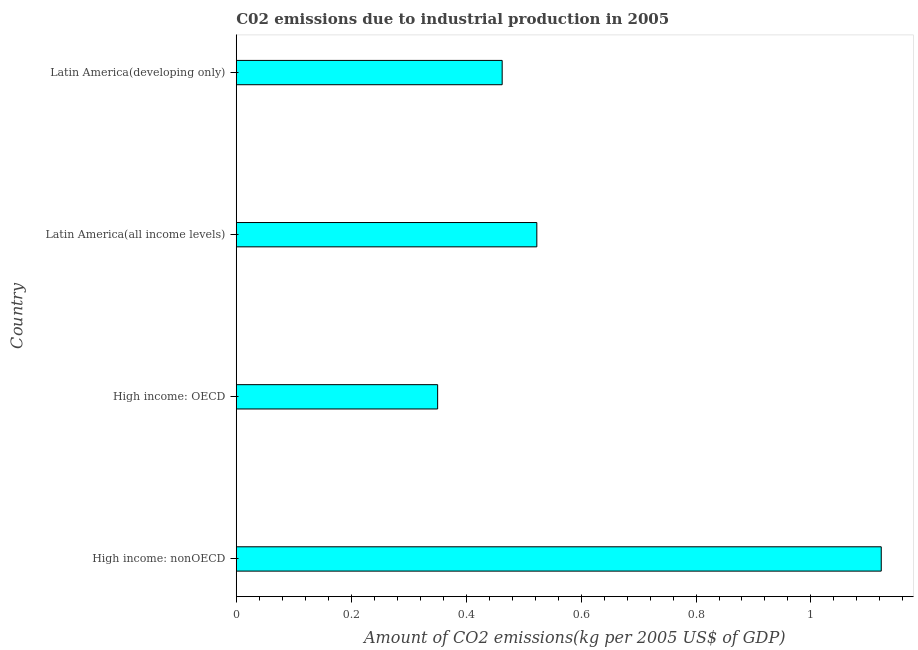Does the graph contain grids?
Provide a succinct answer. No. What is the title of the graph?
Provide a succinct answer. C02 emissions due to industrial production in 2005. What is the label or title of the X-axis?
Provide a succinct answer. Amount of CO2 emissions(kg per 2005 US$ of GDP). What is the amount of co2 emissions in High income: nonOECD?
Your answer should be compact. 1.12. Across all countries, what is the maximum amount of co2 emissions?
Your response must be concise. 1.12. Across all countries, what is the minimum amount of co2 emissions?
Make the answer very short. 0.35. In which country was the amount of co2 emissions maximum?
Your answer should be very brief. High income: nonOECD. In which country was the amount of co2 emissions minimum?
Keep it short and to the point. High income: OECD. What is the sum of the amount of co2 emissions?
Offer a terse response. 2.46. What is the difference between the amount of co2 emissions in High income: OECD and Latin America(developing only)?
Provide a short and direct response. -0.11. What is the average amount of co2 emissions per country?
Keep it short and to the point. 0.61. What is the median amount of co2 emissions?
Provide a succinct answer. 0.49. In how many countries, is the amount of co2 emissions greater than 0.64 kg per 2005 US$ of GDP?
Offer a terse response. 1. What is the ratio of the amount of co2 emissions in High income: nonOECD to that in Latin America(developing only)?
Provide a succinct answer. 2.43. Is the amount of co2 emissions in High income: OECD less than that in Latin America(developing only)?
Your answer should be compact. Yes. What is the difference between the highest and the second highest amount of co2 emissions?
Make the answer very short. 0.6. What is the difference between the highest and the lowest amount of co2 emissions?
Your answer should be very brief. 0.77. What is the difference between two consecutive major ticks on the X-axis?
Your answer should be very brief. 0.2. Are the values on the major ticks of X-axis written in scientific E-notation?
Provide a succinct answer. No. What is the Amount of CO2 emissions(kg per 2005 US$ of GDP) of High income: nonOECD?
Your answer should be very brief. 1.12. What is the Amount of CO2 emissions(kg per 2005 US$ of GDP) of High income: OECD?
Offer a terse response. 0.35. What is the Amount of CO2 emissions(kg per 2005 US$ of GDP) of Latin America(all income levels)?
Keep it short and to the point. 0.52. What is the Amount of CO2 emissions(kg per 2005 US$ of GDP) in Latin America(developing only)?
Ensure brevity in your answer.  0.46. What is the difference between the Amount of CO2 emissions(kg per 2005 US$ of GDP) in High income: nonOECD and High income: OECD?
Provide a short and direct response. 0.77. What is the difference between the Amount of CO2 emissions(kg per 2005 US$ of GDP) in High income: nonOECD and Latin America(all income levels)?
Offer a terse response. 0.6. What is the difference between the Amount of CO2 emissions(kg per 2005 US$ of GDP) in High income: nonOECD and Latin America(developing only)?
Ensure brevity in your answer.  0.66. What is the difference between the Amount of CO2 emissions(kg per 2005 US$ of GDP) in High income: OECD and Latin America(all income levels)?
Provide a succinct answer. -0.17. What is the difference between the Amount of CO2 emissions(kg per 2005 US$ of GDP) in High income: OECD and Latin America(developing only)?
Ensure brevity in your answer.  -0.11. What is the difference between the Amount of CO2 emissions(kg per 2005 US$ of GDP) in Latin America(all income levels) and Latin America(developing only)?
Ensure brevity in your answer.  0.06. What is the ratio of the Amount of CO2 emissions(kg per 2005 US$ of GDP) in High income: nonOECD to that in High income: OECD?
Your answer should be very brief. 3.2. What is the ratio of the Amount of CO2 emissions(kg per 2005 US$ of GDP) in High income: nonOECD to that in Latin America(all income levels)?
Provide a succinct answer. 2.15. What is the ratio of the Amount of CO2 emissions(kg per 2005 US$ of GDP) in High income: nonOECD to that in Latin America(developing only)?
Provide a succinct answer. 2.43. What is the ratio of the Amount of CO2 emissions(kg per 2005 US$ of GDP) in High income: OECD to that in Latin America(all income levels)?
Ensure brevity in your answer.  0.67. What is the ratio of the Amount of CO2 emissions(kg per 2005 US$ of GDP) in High income: OECD to that in Latin America(developing only)?
Your answer should be compact. 0.76. What is the ratio of the Amount of CO2 emissions(kg per 2005 US$ of GDP) in Latin America(all income levels) to that in Latin America(developing only)?
Offer a very short reply. 1.13. 